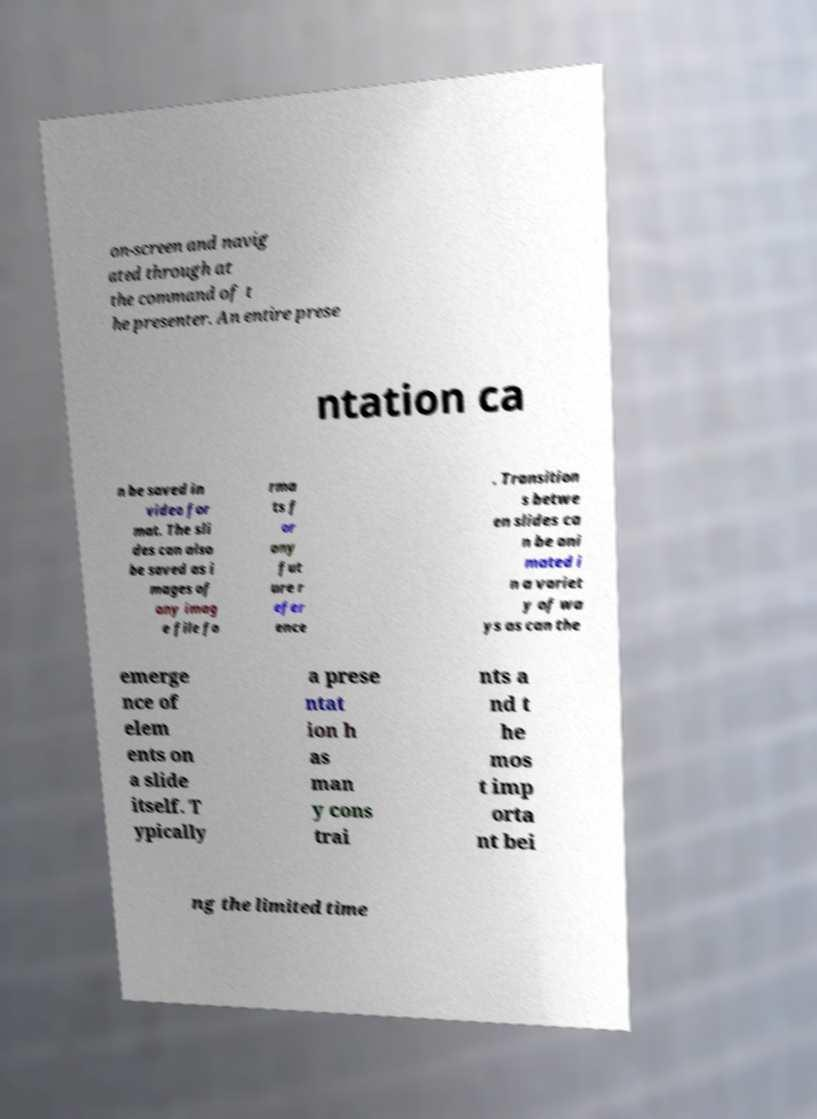Please read and relay the text visible in this image. What does it say? on-screen and navig ated through at the command of t he presenter. An entire prese ntation ca n be saved in video for mat. The sli des can also be saved as i mages of any imag e file fo rma ts f or any fut ure r efer ence . Transition s betwe en slides ca n be ani mated i n a variet y of wa ys as can the emerge nce of elem ents on a slide itself. T ypically a prese ntat ion h as man y cons trai nts a nd t he mos t imp orta nt bei ng the limited time 